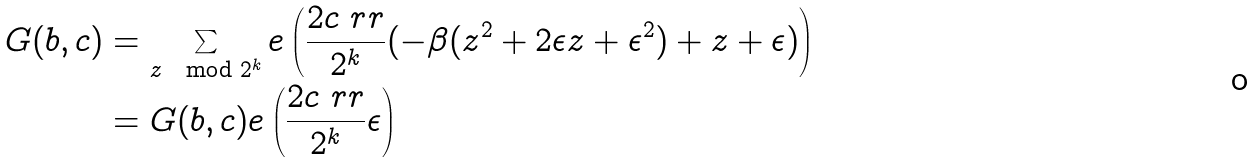<formula> <loc_0><loc_0><loc_500><loc_500>G ( b , c ) & = \sum _ { z \mod 2 ^ { k } } e \left ( \frac { 2 c \ r r } { 2 ^ { k } } ( - \beta ( z ^ { 2 } + 2 \epsilon z + \epsilon ^ { 2 } ) + z + \epsilon ) \right ) \\ & = G ( b , c ) e \left ( \frac { 2 c \ r r } { 2 ^ { k } } \epsilon \right )</formula> 